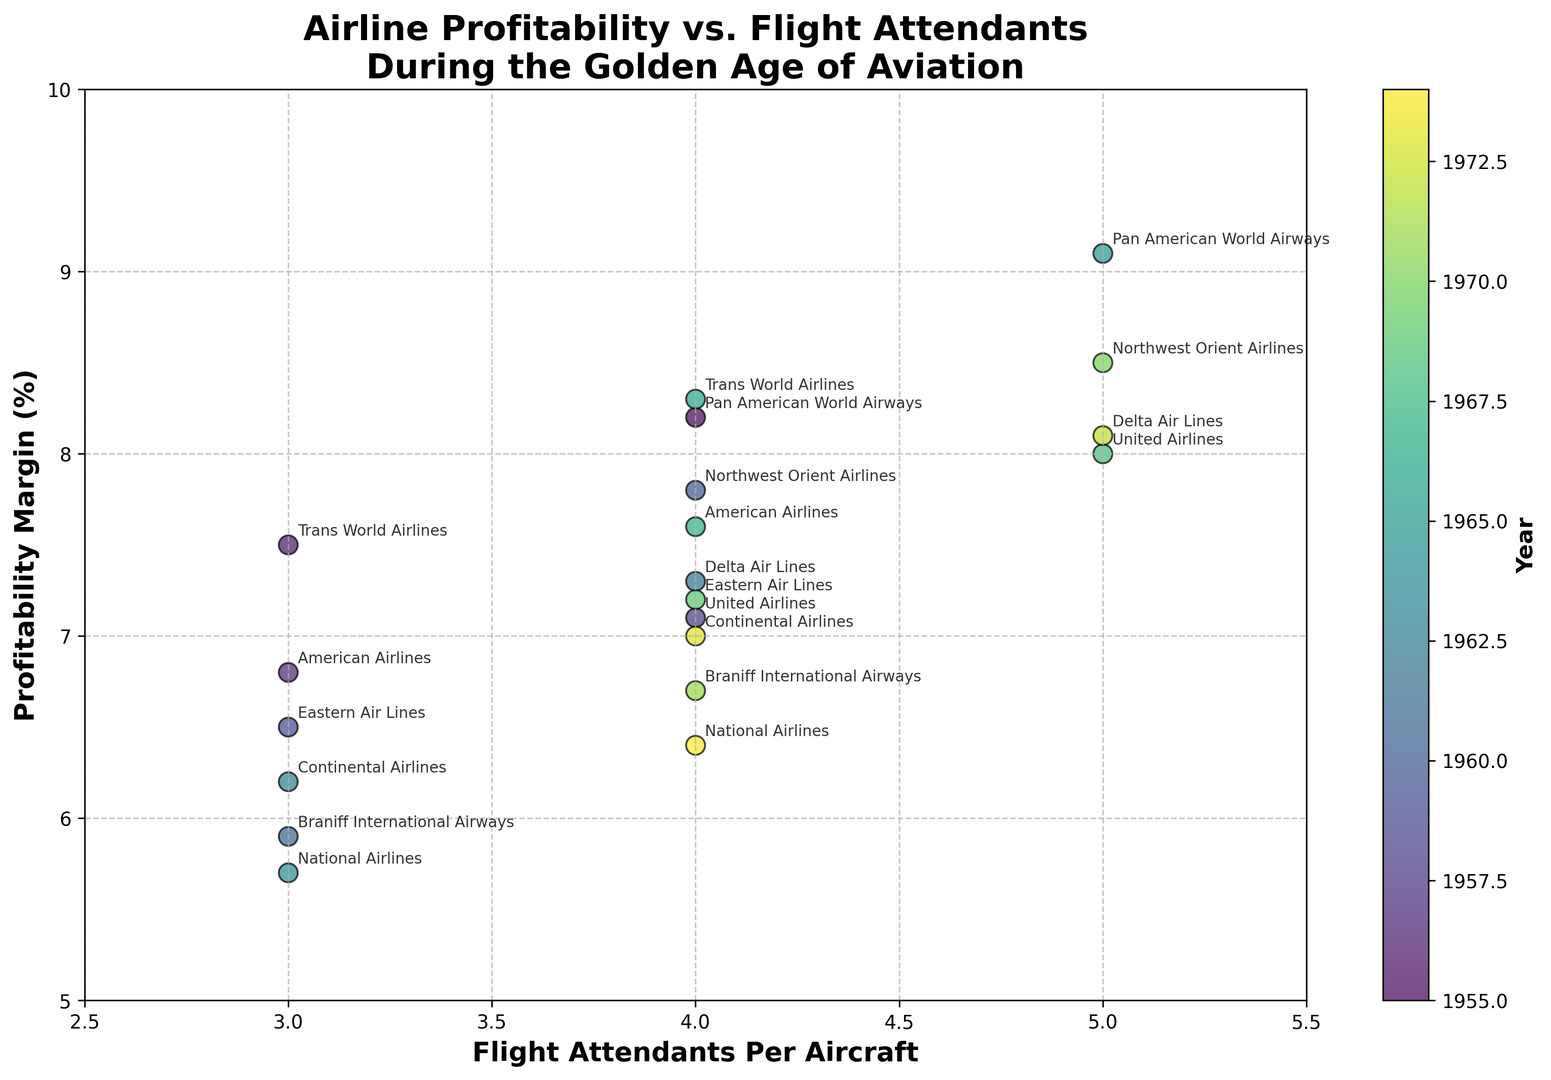Which airline has the highest profitability margin and how many flight attendants per aircraft does it have? The airline with the highest profitability margin is identified by locating the data point with the highest vertical position (profitability margin) on the scatter plot. The airline with the highest profitability margin is Pan American World Airways, having a profitability margin of 9.1%. It corresponds to a data point at 5 flight attendants per aircraft.
Answer: Pan American World Airways has 5 flight attendants per aircraft Which year corresponds to the data point with the lowest profitability margin? The data point with the lowest profitability margin will be the one positioned at the lowest vertical position on the scatter plot. The point with the lowest profitability margin is 5.7%. According to the color gradient representing years, this corresponds to 1964, where National Airlines operated.
Answer: 1964 Is there a general trend between the number of flight attendants per aircraft and profitability margin? By observing the scatter plot, most of the higher profitability margins seem to cluster around data points with 4 to 5 flight attendants per aircraft. This can be considered an indication of a positive correlation where an increase in the number of flight attendants per aircraft tends to associate with a higher profitability margin.
Answer: Positive trend How many data points correspond to 5 flight attendants per aircraft? Identification of data points aligned vertically at 5 flight attendants per aircraft will provide the necessary count. Based on the plot, there are 5 data points for 5 flight attendants per aircraft.
Answer: 5 Which airline had a profitability margin closest to 8% but not exceeding it, and how many flight attendants per aircraft did they have? To answer this, locate the data points close to but not exceeding the 8% profitability margin mark. The airline closest to 8% without exceeding it is Delta Air Lines with an 8.1% profitability margin having 5 flight attendants per aircraft.
Answer: Delta Air Lines had 5 flight attendants per aircraft What is the approximate average profitability margin of airlines with 4 flight attendants per aircraft? Calculate the average of the profitability margins for data points corresponding to 4 flight attendants per aircraft. The relevant data points are: 8.2%, 7.1%, 7.8%, 7.3%, 8.3%, 7.6%, 7.2%, 6.7%, 7.0%, and 6.4%. Sum these values (67.6) and divide by the number of points (10).
Answer: Approximately 6.76% How does the profitability margin for Eastern Air Lines in 1959 compare to its profitability margin in 1969? Locate the data points for Eastern Air Lines in 1959 (6.5%) and 1969 (7.2%), and compare their vertical positions. Eastern Air Lines had a higher profitability margin in 1969 compared to 1959.
Answer: Higher in 1969 Which airline operating the New York-Rome route has the highest profitability margin, and in what year? Find the data point labeled "New York-Rome" associated with Pan American World Airways which has a profitability margin of 9.1%, which is the only route between these two cities within the given data. The year is 1965.
Answer: Pan American World Airways, 1965 Which data point has the color that corresponds to the latest year and what are its flight attendants per aircraft and profitability margin? Check the color gradient on the plot to identify the data point representing the latest year. The latest year is 1974, and the plotting point belongs to National Airlines with a profitability margin of 6.4% and 4 flight attendants per aircraft.
Answer: 4 flight attendants per aircraft, 6.4% 